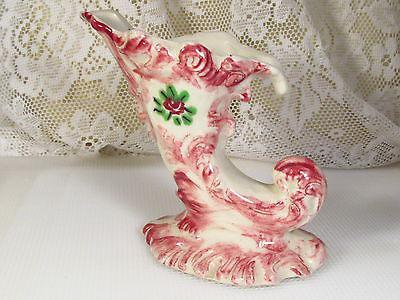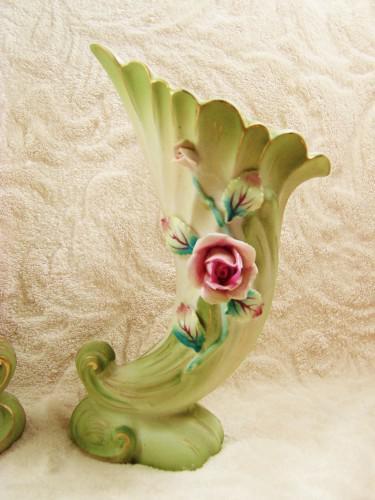The first image is the image on the left, the second image is the image on the right. For the images displayed, is the sentence "None of the vases contain flowers." factually correct? Answer yes or no. Yes. The first image is the image on the left, the second image is the image on the right. For the images shown, is this caption "None of the vases have flowers inserted into them." true? Answer yes or no. Yes. 